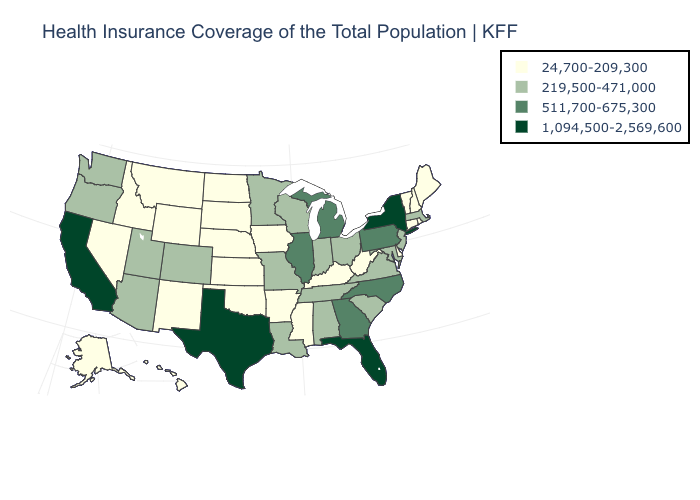Name the states that have a value in the range 219,500-471,000?
Be succinct. Alabama, Arizona, Colorado, Indiana, Louisiana, Maryland, Massachusetts, Minnesota, Missouri, New Jersey, Ohio, Oregon, South Carolina, Tennessee, Utah, Virginia, Washington, Wisconsin. What is the value of Alaska?
Quick response, please. 24,700-209,300. What is the highest value in the Northeast ?
Quick response, please. 1,094,500-2,569,600. Among the states that border Kansas , does Oklahoma have the lowest value?
Keep it brief. Yes. Does Texas have the highest value in the USA?
Short answer required. Yes. What is the value of Maryland?
Answer briefly. 219,500-471,000. Does Vermont have the same value as Alaska?
Concise answer only. Yes. Does Utah have a lower value than Idaho?
Write a very short answer. No. Does the first symbol in the legend represent the smallest category?
Quick response, please. Yes. What is the value of Idaho?
Answer briefly. 24,700-209,300. What is the value of Rhode Island?
Keep it brief. 24,700-209,300. Name the states that have a value in the range 511,700-675,300?
Give a very brief answer. Georgia, Illinois, Michigan, North Carolina, Pennsylvania. Which states have the lowest value in the USA?
Be succinct. Alaska, Arkansas, Connecticut, Delaware, Hawaii, Idaho, Iowa, Kansas, Kentucky, Maine, Mississippi, Montana, Nebraska, Nevada, New Hampshire, New Mexico, North Dakota, Oklahoma, Rhode Island, South Dakota, Vermont, West Virginia, Wyoming. What is the value of Maryland?
Give a very brief answer. 219,500-471,000. Among the states that border Delaware , which have the lowest value?
Short answer required. Maryland, New Jersey. 